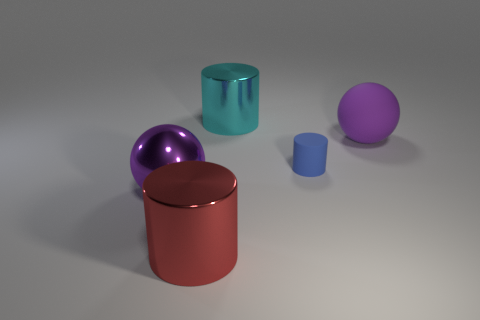What color is the large shiny thing that is right of the purple shiny thing and in front of the rubber cylinder?
Keep it short and to the point. Red. What color is the metallic cylinder on the left side of the metallic object behind the purple ball that is in front of the purple rubber ball?
Your answer should be very brief. Red. What color is the other metallic cylinder that is the same size as the red shiny cylinder?
Provide a short and direct response. Cyan. There is a big purple object that is to the left of the large purple sphere to the right of the shiny cylinder right of the red metallic object; what is its shape?
Provide a short and direct response. Sphere. What shape is the object that is the same color as the matte ball?
Your response must be concise. Sphere. What number of objects are either big green shiny balls or big spheres that are in front of the big purple rubber ball?
Provide a short and direct response. 1. There is a metal cylinder that is behind the purple metal object; does it have the same size as the large rubber ball?
Make the answer very short. Yes. What material is the large sphere that is on the left side of the cyan cylinder?
Your response must be concise. Metal. Is the number of big cyan metallic cylinders that are in front of the purple matte thing the same as the number of rubber cylinders to the left of the blue rubber object?
Ensure brevity in your answer.  Yes. The other big metallic thing that is the same shape as the red metallic thing is what color?
Offer a terse response. Cyan. 